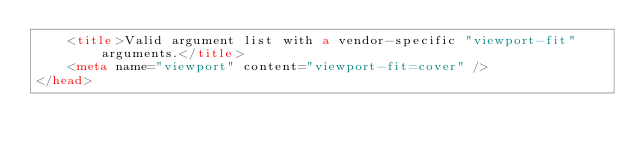Convert code to text. <code><loc_0><loc_0><loc_500><loc_500><_HTML_>    <title>Valid argument list with a vendor-specific "viewport-fit" arguments.</title>
    <meta name="viewport" content="viewport-fit=cover" />
</head>
</code> 